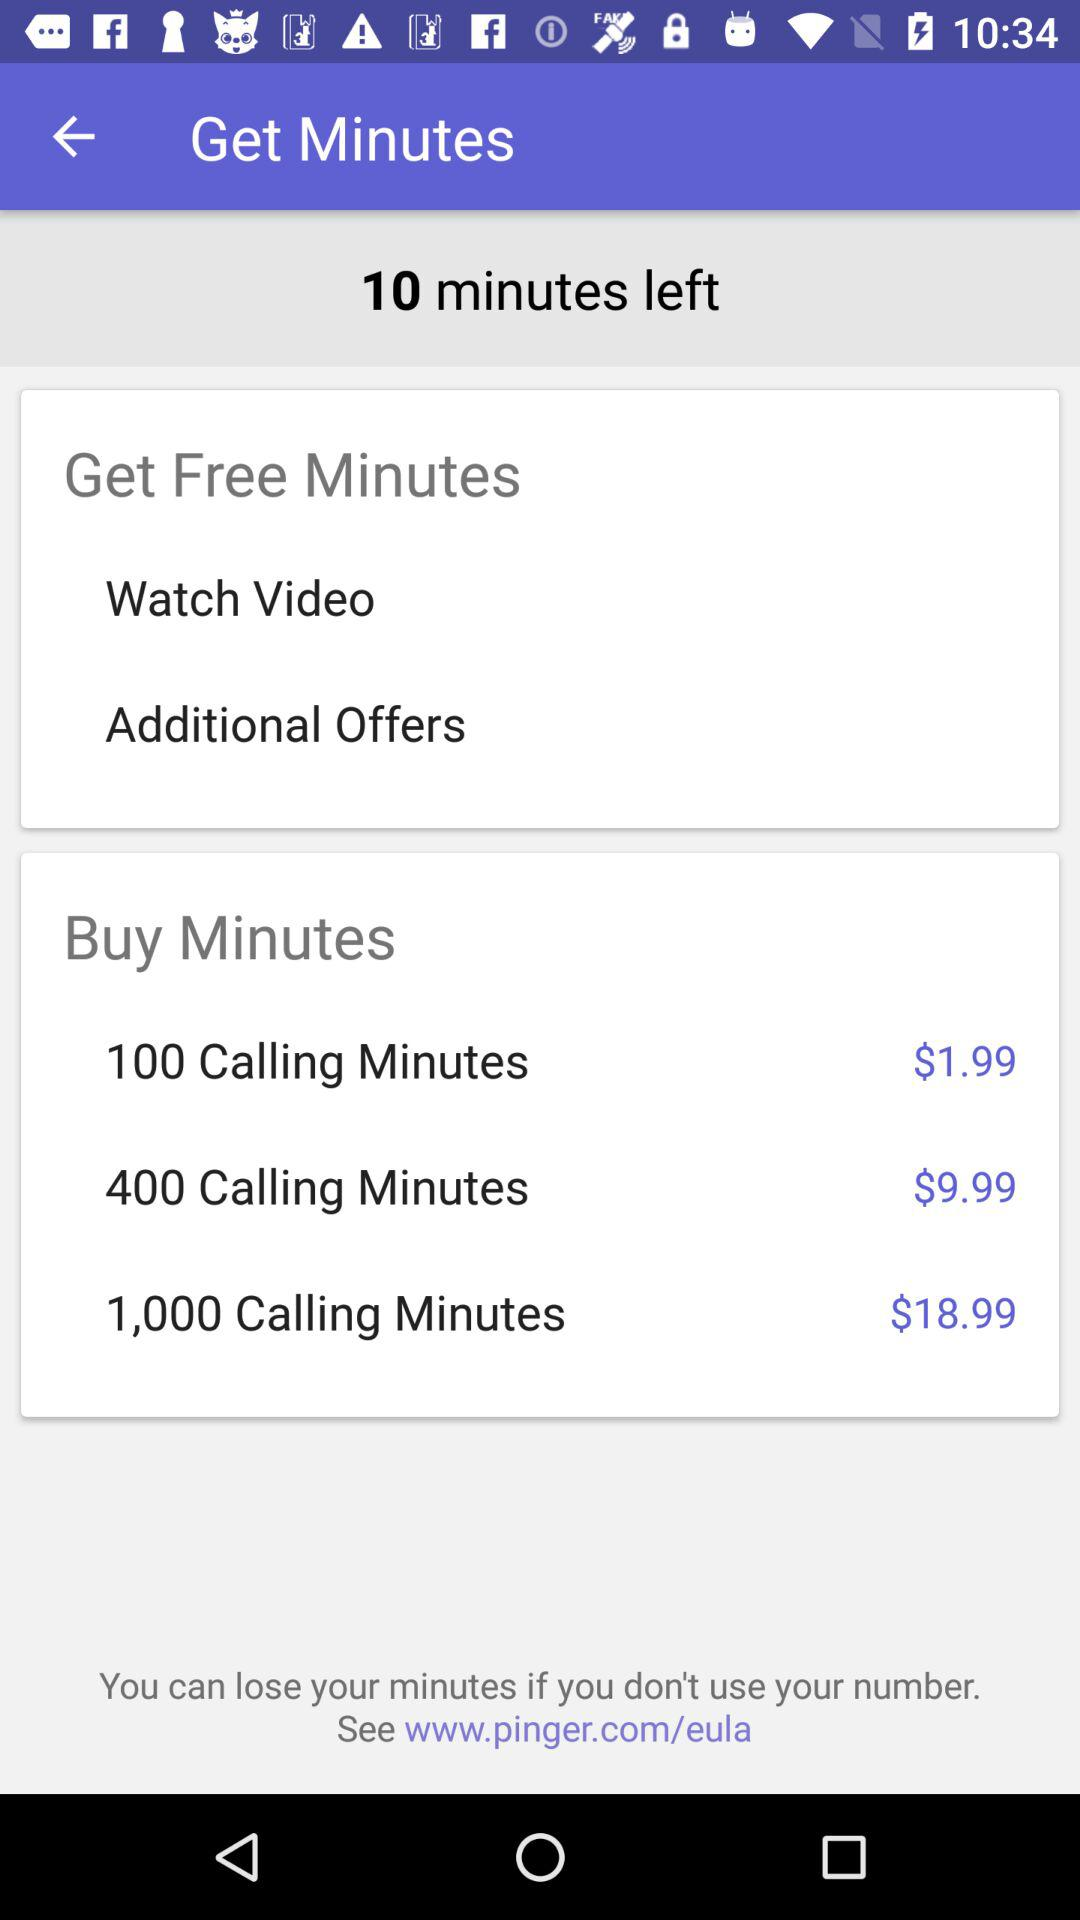How many minutes are left? There are 10 minutes left. 